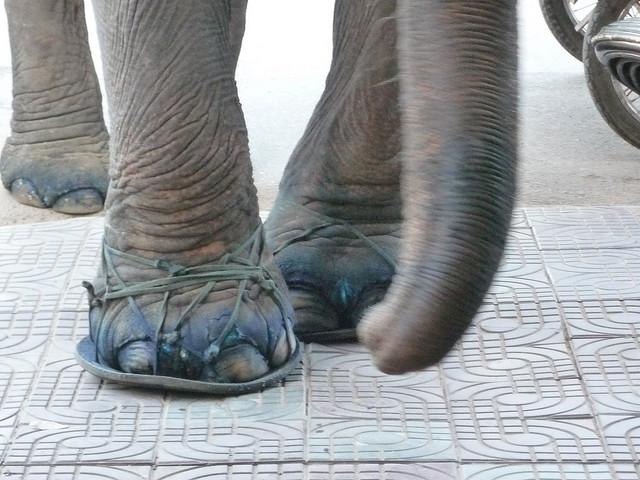Do you want some shoes like the elephant?
Quick response, please. No. Why does the elephant have a shoe around two of its feet?
Answer briefly. Injured. What color is this elephant?
Keep it brief. Gray. Is the elephant eating?
Keep it brief. No. 